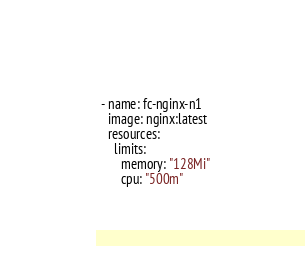Convert code to text. <code><loc_0><loc_0><loc_500><loc_500><_YAML_>  - name: fc-nginx-n1
    image: nginx:latest
    resources:
      limits:
        memory: "128Mi"
        cpu: "500m"</code> 